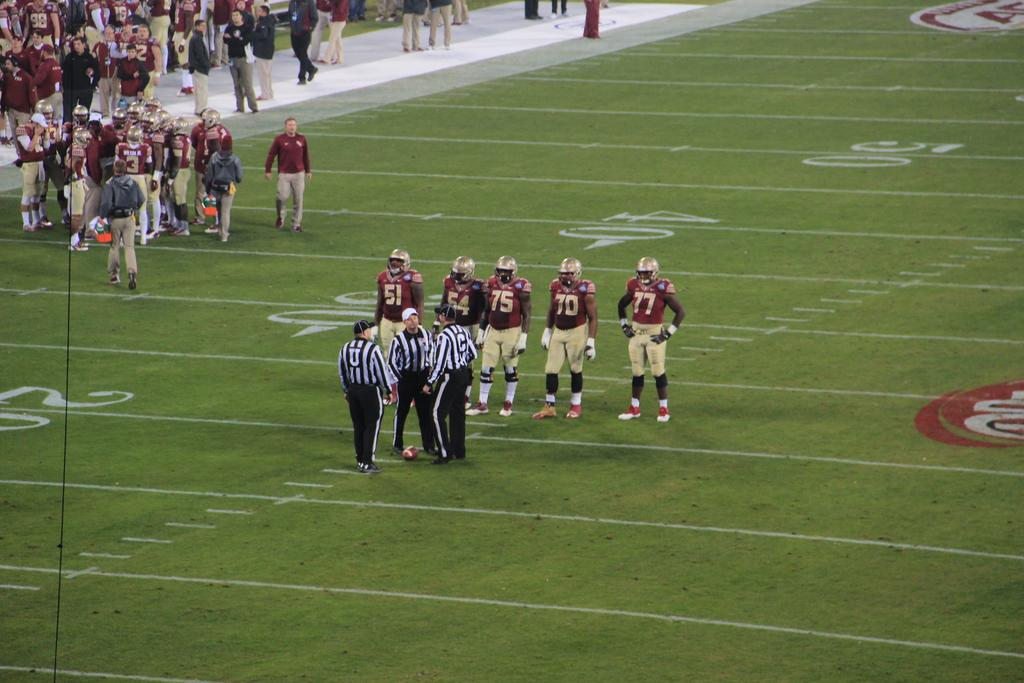What is the main subject of the image? The main subject of the image is a group of people. What are the people in the image doing? The people are standing. What can be observed about the clothing of the people in the image? The people are wearing different color dresses. What other object is present in the image besides the people? There is a ball in the image. How many insects can be seen crawling on the people's dresses in the image? There are no insects visible on the people's dresses in the image. What type of spiders are present in the image? There are no spiders present in the image. 